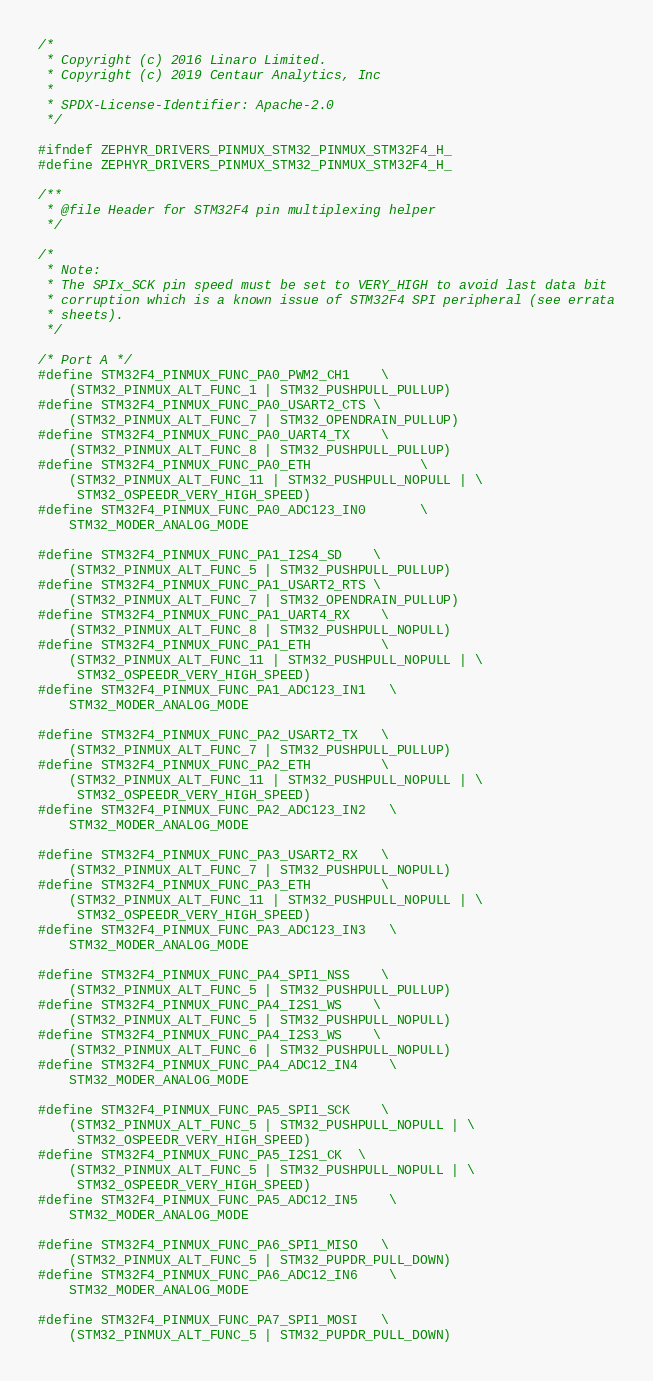<code> <loc_0><loc_0><loc_500><loc_500><_C_>/*
 * Copyright (c) 2016 Linaro Limited.
 * Copyright (c) 2019 Centaur Analytics, Inc
 *
 * SPDX-License-Identifier: Apache-2.0
 */

#ifndef ZEPHYR_DRIVERS_PINMUX_STM32_PINMUX_STM32F4_H_
#define ZEPHYR_DRIVERS_PINMUX_STM32_PINMUX_STM32F4_H_

/**
 * @file Header for STM32F4 pin multiplexing helper
 */

/*
 * Note:
 * The SPIx_SCK pin speed must be set to VERY_HIGH to avoid last data bit
 * corruption which is a known issue of STM32F4 SPI peripheral (see errata
 * sheets).
 */

/* Port A */
#define STM32F4_PINMUX_FUNC_PA0_PWM2_CH1    \
	(STM32_PINMUX_ALT_FUNC_1 | STM32_PUSHPULL_PULLUP)
#define STM32F4_PINMUX_FUNC_PA0_USART2_CTS \
	(STM32_PINMUX_ALT_FUNC_7 | STM32_OPENDRAIN_PULLUP)
#define STM32F4_PINMUX_FUNC_PA0_UART4_TX    \
	(STM32_PINMUX_ALT_FUNC_8 | STM32_PUSHPULL_PULLUP)
#define STM32F4_PINMUX_FUNC_PA0_ETH			    \
	(STM32_PINMUX_ALT_FUNC_11 | STM32_PUSHPULL_NOPULL | \
	 STM32_OSPEEDR_VERY_HIGH_SPEED)
#define STM32F4_PINMUX_FUNC_PA0_ADC123_IN0		\
	STM32_MODER_ANALOG_MODE

#define STM32F4_PINMUX_FUNC_PA1_I2S4_SD    \
	(STM32_PINMUX_ALT_FUNC_5 | STM32_PUSHPULL_PULLUP)
#define STM32F4_PINMUX_FUNC_PA1_USART2_RTS \
	(STM32_PINMUX_ALT_FUNC_7 | STM32_OPENDRAIN_PULLUP)
#define STM32F4_PINMUX_FUNC_PA1_UART4_RX    \
	(STM32_PINMUX_ALT_FUNC_8 | STM32_PUSHPULL_NOPULL)
#define STM32F4_PINMUX_FUNC_PA1_ETH         \
	(STM32_PINMUX_ALT_FUNC_11 | STM32_PUSHPULL_NOPULL | \
	 STM32_OSPEEDR_VERY_HIGH_SPEED)
#define STM32F4_PINMUX_FUNC_PA1_ADC123_IN1	\
	STM32_MODER_ANALOG_MODE

#define STM32F4_PINMUX_FUNC_PA2_USART2_TX   \
	(STM32_PINMUX_ALT_FUNC_7 | STM32_PUSHPULL_PULLUP)
#define STM32F4_PINMUX_FUNC_PA2_ETH         \
	(STM32_PINMUX_ALT_FUNC_11 | STM32_PUSHPULL_NOPULL | \
	 STM32_OSPEEDR_VERY_HIGH_SPEED)
#define STM32F4_PINMUX_FUNC_PA2_ADC123_IN2	\
	STM32_MODER_ANALOG_MODE

#define STM32F4_PINMUX_FUNC_PA3_USART2_RX   \
	(STM32_PINMUX_ALT_FUNC_7 | STM32_PUSHPULL_NOPULL)
#define STM32F4_PINMUX_FUNC_PA3_ETH         \
	(STM32_PINMUX_ALT_FUNC_11 | STM32_PUSHPULL_NOPULL | \
	 STM32_OSPEEDR_VERY_HIGH_SPEED)
#define STM32F4_PINMUX_FUNC_PA3_ADC123_IN3	\
	STM32_MODER_ANALOG_MODE

#define STM32F4_PINMUX_FUNC_PA4_SPI1_NSS    \
	(STM32_PINMUX_ALT_FUNC_5 | STM32_PUSHPULL_PULLUP)
#define STM32F4_PINMUX_FUNC_PA4_I2S1_WS    \
	(STM32_PINMUX_ALT_FUNC_5 | STM32_PUSHPULL_NOPULL)
#define STM32F4_PINMUX_FUNC_PA4_I2S3_WS    \
	(STM32_PINMUX_ALT_FUNC_6 | STM32_PUSHPULL_NOPULL)
#define STM32F4_PINMUX_FUNC_PA4_ADC12_IN4	\
	STM32_MODER_ANALOG_MODE

#define STM32F4_PINMUX_FUNC_PA5_SPI1_SCK    \
	(STM32_PINMUX_ALT_FUNC_5 | STM32_PUSHPULL_NOPULL | \
	 STM32_OSPEEDR_VERY_HIGH_SPEED)
#define STM32F4_PINMUX_FUNC_PA5_I2S1_CK  \
	(STM32_PINMUX_ALT_FUNC_5 | STM32_PUSHPULL_NOPULL | \
	 STM32_OSPEEDR_VERY_HIGH_SPEED)
#define STM32F4_PINMUX_FUNC_PA5_ADC12_IN5	\
	STM32_MODER_ANALOG_MODE

#define STM32F4_PINMUX_FUNC_PA6_SPI1_MISO   \
	(STM32_PINMUX_ALT_FUNC_5 | STM32_PUPDR_PULL_DOWN)
#define STM32F4_PINMUX_FUNC_PA6_ADC12_IN6	\
	STM32_MODER_ANALOG_MODE

#define STM32F4_PINMUX_FUNC_PA7_SPI1_MOSI   \
	(STM32_PINMUX_ALT_FUNC_5 | STM32_PUPDR_PULL_DOWN)</code> 